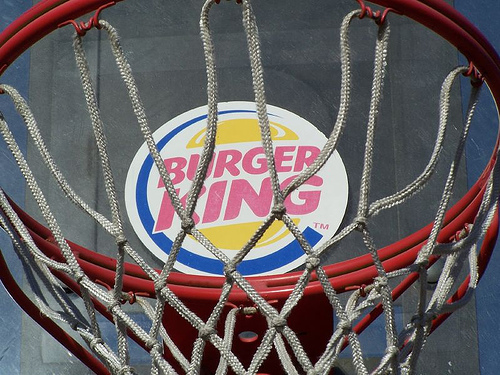<image>
Can you confirm if the sign is on the rope? No. The sign is not positioned on the rope. They may be near each other, but the sign is not supported by or resting on top of the rope. 